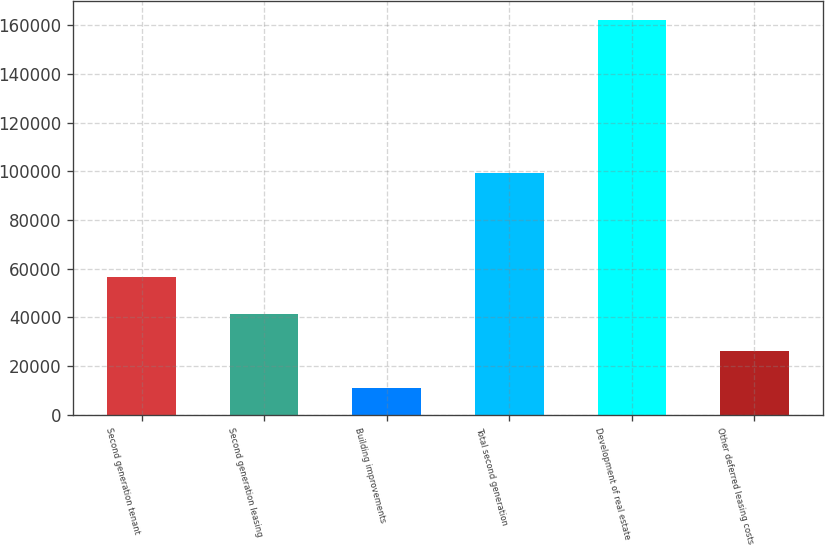Convert chart. <chart><loc_0><loc_0><loc_500><loc_500><bar_chart><fcel>Second generation tenant<fcel>Second generation leasing<fcel>Building improvements<fcel>Total second generation<fcel>Development of real estate<fcel>Other deferred leasing costs<nl><fcel>56514<fcel>41412.5<fcel>11055<fcel>99264<fcel>162070<fcel>26311<nl></chart> 